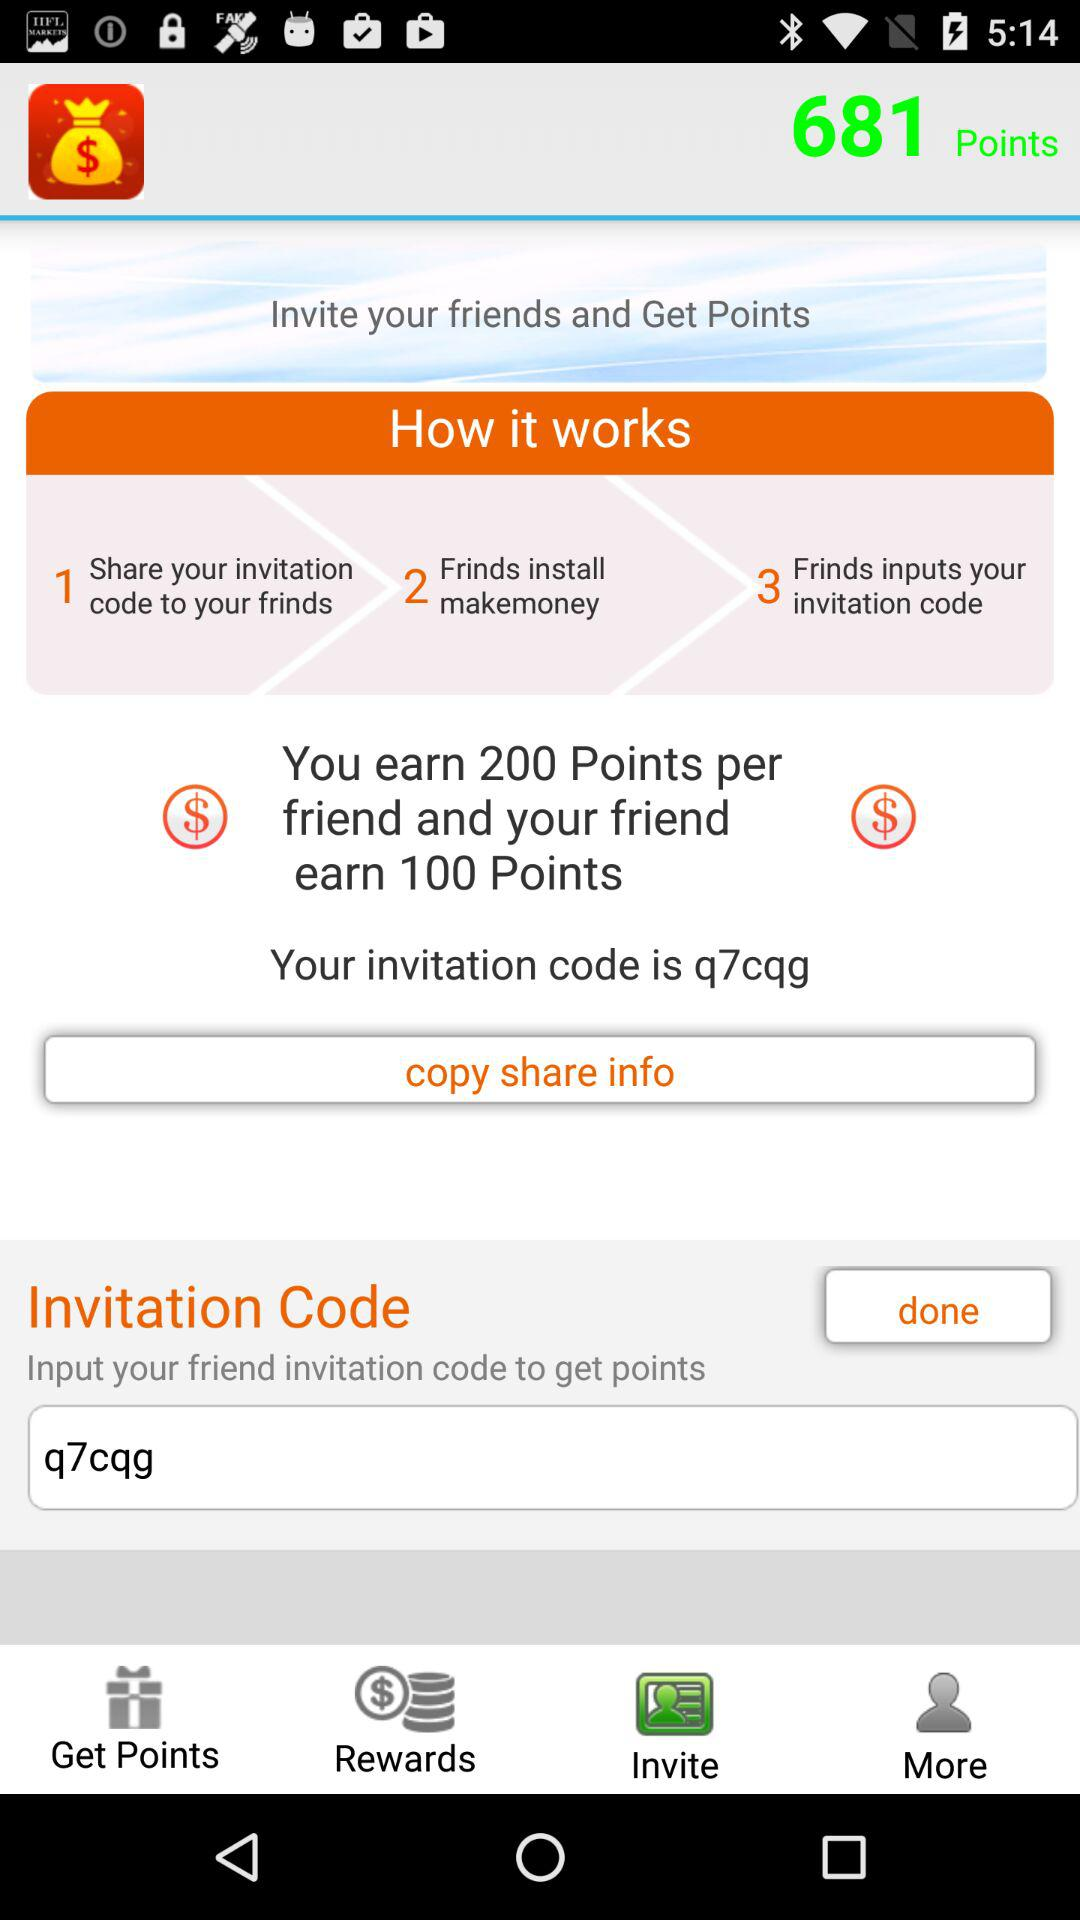How many friends have been invited?
When the provided information is insufficient, respond with <no answer>. <no answer> 